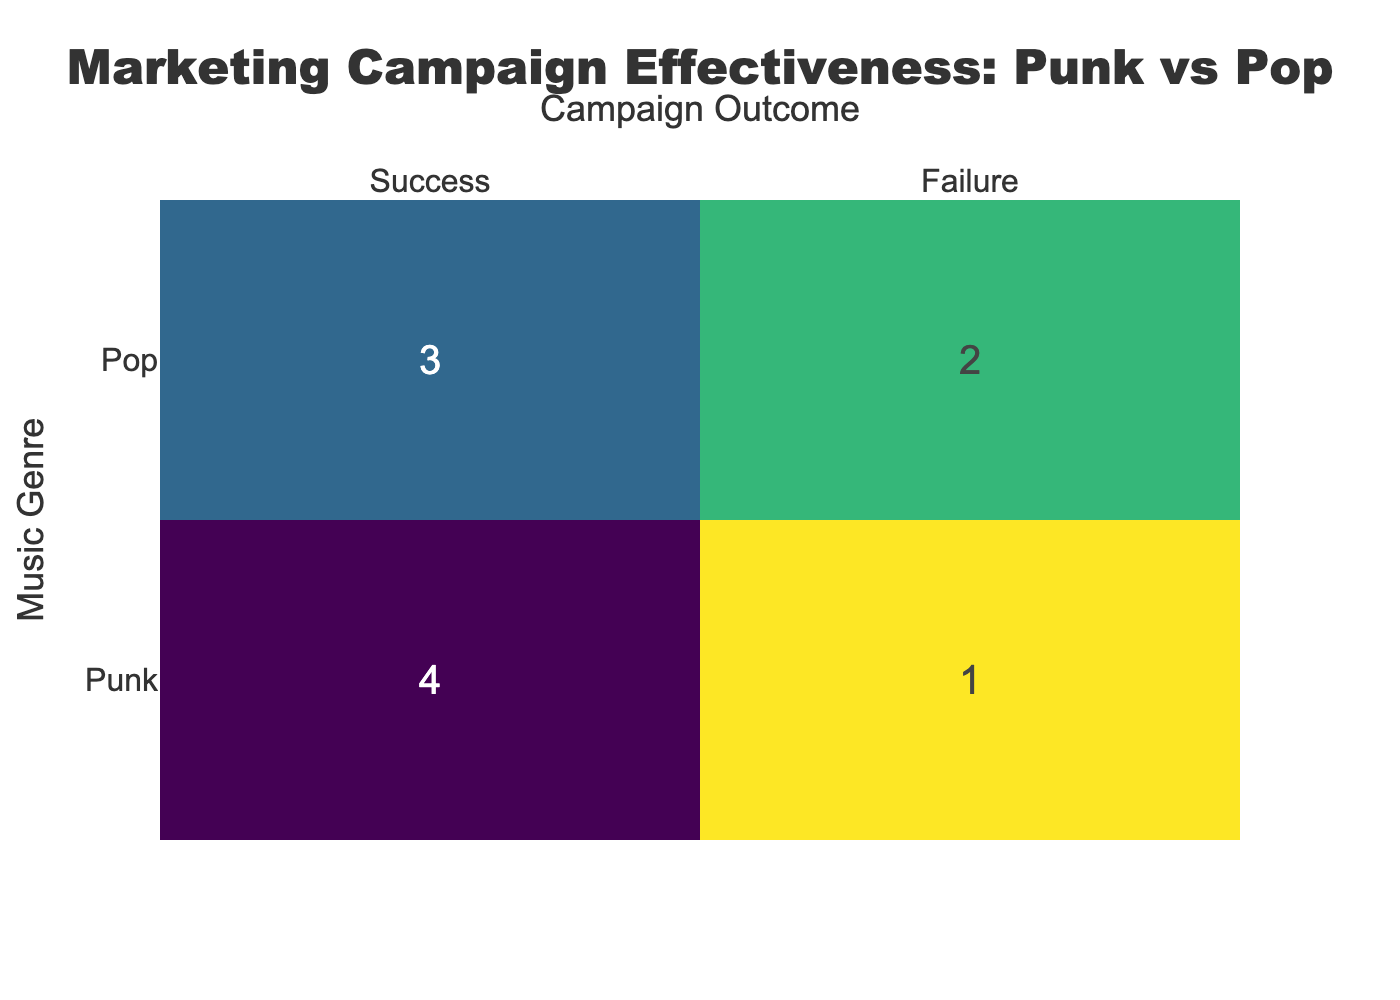What is the number of successful marketing campaigns for Punk music? In the table, the successful campaigns for Punk music are "Green Day - Father of All Motherf***ers Launch", "Fall Out Boy - MANIA Promo", "Paramore - After Laughter Promo", and "Anti-Flag - 20/20 Vision Marketing". Counting these gives us 4 successful campaigns.
Answer: 4 What is the total number of marketing campaigns for Pop music? The marketing campaigns for Pop music listed in the table are "Dua Lipa - Future Nostalgia Campaign", "Billie Eilish - Happier Than Ever Release", "Taylor Swift - Lover Marketing Strategy", "Ed Sheeran - No.6 Collaborations Project", and "Ariana Grande - Positions Campaign". There are 5 campaigns total.
Answer: 5 Did any Pop music campaigns fail? The campaign "Billie Eilish - Happier Than Ever Release" and "Ariana Grande - Positions Campaign" are marked as False in the 'Successfully Reached Audience' column, indicating they failed. Therefore, there are campaigns that failed in Pop music.
Answer: Yes Which genre has a higher success rate in marketing campaigns? We calculate the success rates: Punk has 4 successful out of 6 total campaigns (4/6 = 66.67%), while Pop has 3 successful out of 5 total campaigns (3/5 = 60%). Since 66.67% is greater than 60%, Punk has the higher success rate.
Answer: Punk How many total failures were recorded for Punk music campaigns? The campaigns that failed for Punk music are "Blink-182 - Nine Marketing Push". Since there is only one failure here, the total number of failures recorded for Punk music is 1.
Answer: 1 What is the average ROI for successful marketing campaigns? The ROIs for successful campaigns are 300%, 250%, 500%, 350%, 350%, and 400%, which sums to (300 + 250 + 500 + 350 + 350 + 400) = 2150%. There are 6 successful campaigns, so the average ROI is 2150% / 6 = 358.33%.
Answer: 358.33% Is there a campaign with both the highest sales increase and ROI? The campaign "Ed Sheeran - No.6 Collaborations Project" has a sales increase of 45% and an ROI of 600%, which is the highest for both metrics in Pop music. The combined highest values indicate that this is the best campaign.
Answer: Yes Which Punk campaign had the lowest success percentage? The campaigns are ranked as follows: "Blink-182 - Nine Marketing Push" had a sales increase of 10% with a result of failure, thus having the lowest.
Answer: Blink-182 - Nine Marketing Push What is the difference in successful campaigns between Punk and Pop genres? Punk had 4 successful campaigns while Pop had 3. The difference is calculated as 4 (Punk) - 3 (Pop) = 1. Thus, Punk has 1 more successful campaign than Pop.
Answer: 1 